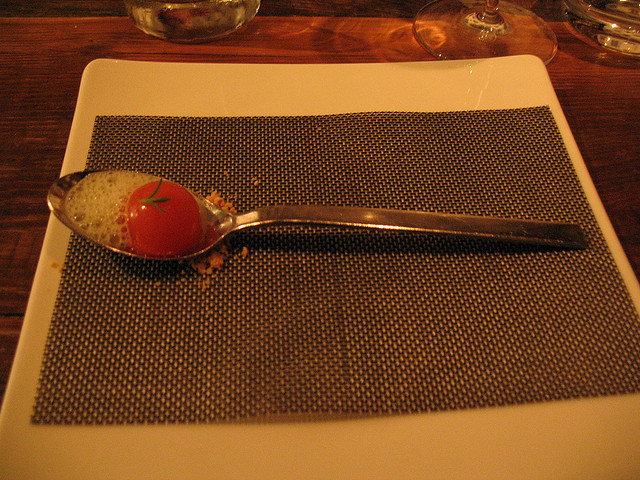What occasion might this food presentation be suitable for? This sophisticated presentation seems fitting for a gourmet dining experience, likely to be found at a high-end restaurant. It might be part of a tasting menu where each dish is crafted to impress both visually and taste-wise. 